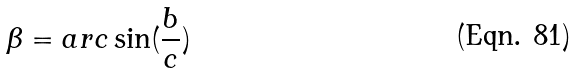<formula> <loc_0><loc_0><loc_500><loc_500>\beta = a r c \sin ( \frac { b } { c } )</formula> 